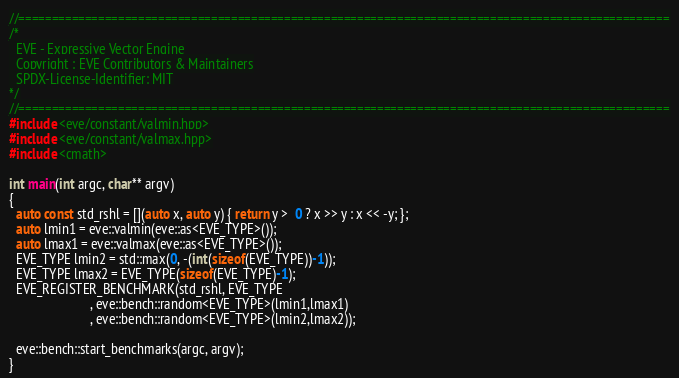<code> <loc_0><loc_0><loc_500><loc_500><_C++_>//==================================================================================================
/*
  EVE - Expressive Vector Engine
  Copyright : EVE Contributors & Maintainers
  SPDX-License-Identifier: MIT
*/
//==================================================================================================
#include <eve/constant/valmin.hpp>
#include <eve/constant/valmax.hpp>
#include <cmath>

int main(int argc, char** argv)
{
  auto const std_rshl = [](auto x, auto y) { return y >  0 ? x >> y : x << -y; };
  auto lmin1 = eve::valmin(eve::as<EVE_TYPE>());
  auto lmax1 = eve::valmax(eve::as<EVE_TYPE>());
  EVE_TYPE lmin2 = std::max(0, -(int(sizeof(EVE_TYPE))-1));
  EVE_TYPE lmax2 = EVE_TYPE(sizeof(EVE_TYPE)-1);
  EVE_REGISTER_BENCHMARK(std_rshl, EVE_TYPE
                        , eve::bench::random<EVE_TYPE>(lmin1,lmax1)
                        , eve::bench::random<EVE_TYPE>(lmin2,lmax2));

  eve::bench::start_benchmarks(argc, argv);
}
</code> 